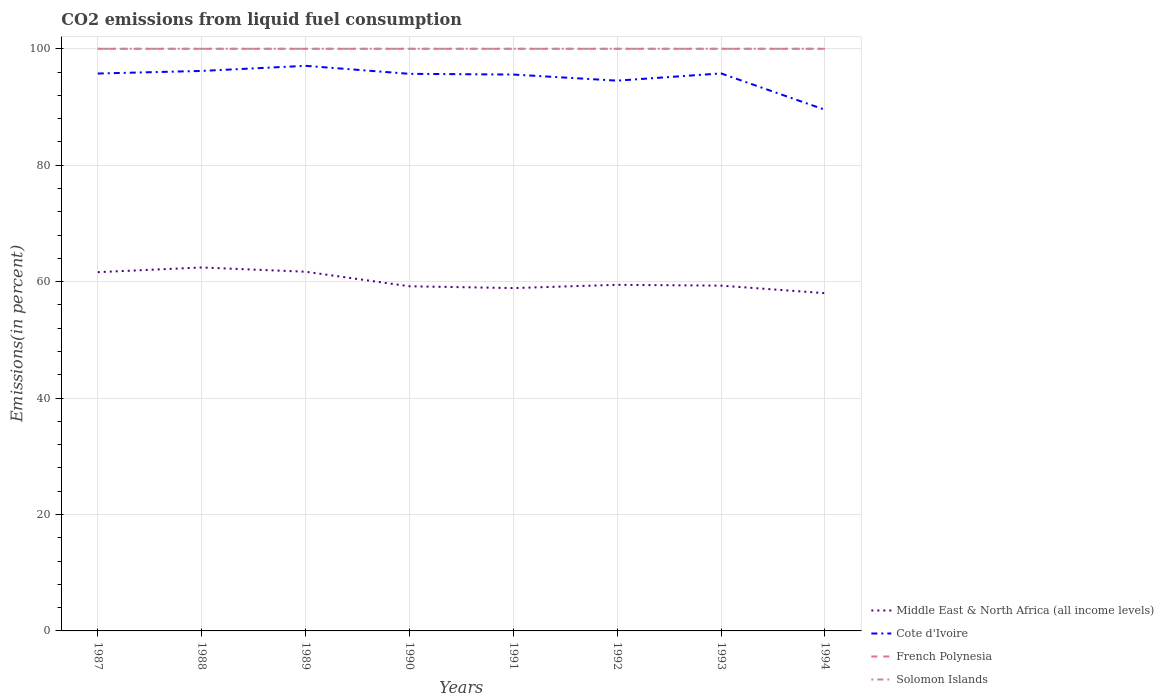Does the line corresponding to French Polynesia intersect with the line corresponding to Cote d'Ivoire?
Provide a short and direct response. No. Is the number of lines equal to the number of legend labels?
Provide a short and direct response. Yes. Across all years, what is the maximum total CO2 emitted in French Polynesia?
Make the answer very short. 100. In which year was the total CO2 emitted in Middle East & North Africa (all income levels) maximum?
Give a very brief answer. 1994. What is the difference between the highest and the lowest total CO2 emitted in Solomon Islands?
Your response must be concise. 0. Is the total CO2 emitted in Cote d'Ivoire strictly greater than the total CO2 emitted in Solomon Islands over the years?
Offer a terse response. Yes. How many years are there in the graph?
Provide a short and direct response. 8. Does the graph contain grids?
Your answer should be compact. Yes. Where does the legend appear in the graph?
Provide a succinct answer. Bottom right. What is the title of the graph?
Offer a terse response. CO2 emissions from liquid fuel consumption. Does "Indonesia" appear as one of the legend labels in the graph?
Make the answer very short. No. What is the label or title of the Y-axis?
Provide a short and direct response. Emissions(in percent). What is the Emissions(in percent) of Middle East & North Africa (all income levels) in 1987?
Your answer should be very brief. 61.63. What is the Emissions(in percent) in Cote d'Ivoire in 1987?
Your answer should be very brief. 95.75. What is the Emissions(in percent) in Middle East & North Africa (all income levels) in 1988?
Ensure brevity in your answer.  62.44. What is the Emissions(in percent) of Cote d'Ivoire in 1988?
Your answer should be very brief. 96.2. What is the Emissions(in percent) in Middle East & North Africa (all income levels) in 1989?
Make the answer very short. 61.7. What is the Emissions(in percent) of Cote d'Ivoire in 1989?
Offer a very short reply. 97.07. What is the Emissions(in percent) in Middle East & North Africa (all income levels) in 1990?
Keep it short and to the point. 59.21. What is the Emissions(in percent) of Cote d'Ivoire in 1990?
Your answer should be very brief. 95.7. What is the Emissions(in percent) in Solomon Islands in 1990?
Ensure brevity in your answer.  100. What is the Emissions(in percent) in Middle East & North Africa (all income levels) in 1991?
Your answer should be compact. 58.89. What is the Emissions(in percent) in Cote d'Ivoire in 1991?
Make the answer very short. 95.58. What is the Emissions(in percent) of French Polynesia in 1991?
Provide a short and direct response. 100. What is the Emissions(in percent) in Solomon Islands in 1991?
Give a very brief answer. 100. What is the Emissions(in percent) in Middle East & North Africa (all income levels) in 1992?
Your answer should be compact. 59.45. What is the Emissions(in percent) of Cote d'Ivoire in 1992?
Offer a very short reply. 94.53. What is the Emissions(in percent) in Solomon Islands in 1992?
Provide a succinct answer. 100. What is the Emissions(in percent) of Middle East & North Africa (all income levels) in 1993?
Keep it short and to the point. 59.31. What is the Emissions(in percent) in Cote d'Ivoire in 1993?
Offer a terse response. 95.77. What is the Emissions(in percent) in French Polynesia in 1993?
Keep it short and to the point. 100. What is the Emissions(in percent) in Middle East & North Africa (all income levels) in 1994?
Your response must be concise. 58.02. What is the Emissions(in percent) of Cote d'Ivoire in 1994?
Offer a terse response. 89.53. What is the Emissions(in percent) in Solomon Islands in 1994?
Provide a succinct answer. 100. Across all years, what is the maximum Emissions(in percent) of Middle East & North Africa (all income levels)?
Offer a very short reply. 62.44. Across all years, what is the maximum Emissions(in percent) in Cote d'Ivoire?
Provide a succinct answer. 97.07. Across all years, what is the maximum Emissions(in percent) in Solomon Islands?
Keep it short and to the point. 100. Across all years, what is the minimum Emissions(in percent) of Middle East & North Africa (all income levels)?
Ensure brevity in your answer.  58.02. Across all years, what is the minimum Emissions(in percent) in Cote d'Ivoire?
Make the answer very short. 89.53. Across all years, what is the minimum Emissions(in percent) of French Polynesia?
Provide a short and direct response. 100. Across all years, what is the minimum Emissions(in percent) in Solomon Islands?
Keep it short and to the point. 100. What is the total Emissions(in percent) of Middle East & North Africa (all income levels) in the graph?
Keep it short and to the point. 480.65. What is the total Emissions(in percent) of Cote d'Ivoire in the graph?
Make the answer very short. 760.12. What is the total Emissions(in percent) in French Polynesia in the graph?
Your response must be concise. 800. What is the total Emissions(in percent) of Solomon Islands in the graph?
Offer a terse response. 800. What is the difference between the Emissions(in percent) of Middle East & North Africa (all income levels) in 1987 and that in 1988?
Your answer should be compact. -0.81. What is the difference between the Emissions(in percent) of Cote d'Ivoire in 1987 and that in 1988?
Offer a very short reply. -0.45. What is the difference between the Emissions(in percent) of Solomon Islands in 1987 and that in 1988?
Make the answer very short. 0. What is the difference between the Emissions(in percent) of Middle East & North Africa (all income levels) in 1987 and that in 1989?
Your response must be concise. -0.07. What is the difference between the Emissions(in percent) in Cote d'Ivoire in 1987 and that in 1989?
Your answer should be compact. -1.32. What is the difference between the Emissions(in percent) in Middle East & North Africa (all income levels) in 1987 and that in 1990?
Your response must be concise. 2.42. What is the difference between the Emissions(in percent) in Cote d'Ivoire in 1987 and that in 1990?
Provide a short and direct response. 0.05. What is the difference between the Emissions(in percent) in Solomon Islands in 1987 and that in 1990?
Your answer should be very brief. 0. What is the difference between the Emissions(in percent) of Middle East & North Africa (all income levels) in 1987 and that in 1991?
Your response must be concise. 2.73. What is the difference between the Emissions(in percent) of Cote d'Ivoire in 1987 and that in 1991?
Provide a short and direct response. 0.18. What is the difference between the Emissions(in percent) in French Polynesia in 1987 and that in 1991?
Provide a short and direct response. 0. What is the difference between the Emissions(in percent) of Middle East & North Africa (all income levels) in 1987 and that in 1992?
Your answer should be very brief. 2.17. What is the difference between the Emissions(in percent) in Cote d'Ivoire in 1987 and that in 1992?
Offer a terse response. 1.22. What is the difference between the Emissions(in percent) of French Polynesia in 1987 and that in 1992?
Your response must be concise. 0. What is the difference between the Emissions(in percent) of Middle East & North Africa (all income levels) in 1987 and that in 1993?
Offer a terse response. 2.32. What is the difference between the Emissions(in percent) of Cote d'Ivoire in 1987 and that in 1993?
Provide a short and direct response. -0.02. What is the difference between the Emissions(in percent) of French Polynesia in 1987 and that in 1993?
Keep it short and to the point. 0. What is the difference between the Emissions(in percent) in Middle East & North Africa (all income levels) in 1987 and that in 1994?
Your answer should be very brief. 3.61. What is the difference between the Emissions(in percent) in Cote d'Ivoire in 1987 and that in 1994?
Give a very brief answer. 6.23. What is the difference between the Emissions(in percent) in French Polynesia in 1987 and that in 1994?
Give a very brief answer. 0. What is the difference between the Emissions(in percent) of Middle East & North Africa (all income levels) in 1988 and that in 1989?
Your response must be concise. 0.73. What is the difference between the Emissions(in percent) in Cote d'Ivoire in 1988 and that in 1989?
Provide a short and direct response. -0.88. What is the difference between the Emissions(in percent) in French Polynesia in 1988 and that in 1989?
Provide a succinct answer. 0. What is the difference between the Emissions(in percent) of Solomon Islands in 1988 and that in 1989?
Your answer should be compact. 0. What is the difference between the Emissions(in percent) of Middle East & North Africa (all income levels) in 1988 and that in 1990?
Your answer should be very brief. 3.23. What is the difference between the Emissions(in percent) in Cote d'Ivoire in 1988 and that in 1990?
Your response must be concise. 0.5. What is the difference between the Emissions(in percent) in Middle East & North Africa (all income levels) in 1988 and that in 1991?
Keep it short and to the point. 3.54. What is the difference between the Emissions(in percent) of Cote d'Ivoire in 1988 and that in 1991?
Ensure brevity in your answer.  0.62. What is the difference between the Emissions(in percent) of French Polynesia in 1988 and that in 1991?
Provide a succinct answer. 0. What is the difference between the Emissions(in percent) in Middle East & North Africa (all income levels) in 1988 and that in 1992?
Offer a very short reply. 2.98. What is the difference between the Emissions(in percent) of Cote d'Ivoire in 1988 and that in 1992?
Provide a succinct answer. 1.67. What is the difference between the Emissions(in percent) of Middle East & North Africa (all income levels) in 1988 and that in 1993?
Ensure brevity in your answer.  3.12. What is the difference between the Emissions(in percent) of Cote d'Ivoire in 1988 and that in 1993?
Offer a terse response. 0.43. What is the difference between the Emissions(in percent) in Middle East & North Africa (all income levels) in 1988 and that in 1994?
Give a very brief answer. 4.41. What is the difference between the Emissions(in percent) of Cote d'Ivoire in 1988 and that in 1994?
Give a very brief answer. 6.67. What is the difference between the Emissions(in percent) in Solomon Islands in 1988 and that in 1994?
Your response must be concise. 0. What is the difference between the Emissions(in percent) in Middle East & North Africa (all income levels) in 1989 and that in 1990?
Your answer should be compact. 2.5. What is the difference between the Emissions(in percent) in Cote d'Ivoire in 1989 and that in 1990?
Make the answer very short. 1.38. What is the difference between the Emissions(in percent) of French Polynesia in 1989 and that in 1990?
Your answer should be very brief. 0. What is the difference between the Emissions(in percent) in Middle East & North Africa (all income levels) in 1989 and that in 1991?
Give a very brief answer. 2.81. What is the difference between the Emissions(in percent) of Cote d'Ivoire in 1989 and that in 1991?
Your answer should be very brief. 1.5. What is the difference between the Emissions(in percent) in Middle East & North Africa (all income levels) in 1989 and that in 1992?
Provide a short and direct response. 2.25. What is the difference between the Emissions(in percent) of Cote d'Ivoire in 1989 and that in 1992?
Give a very brief answer. 2.55. What is the difference between the Emissions(in percent) of French Polynesia in 1989 and that in 1992?
Provide a succinct answer. 0. What is the difference between the Emissions(in percent) in Solomon Islands in 1989 and that in 1992?
Make the answer very short. 0. What is the difference between the Emissions(in percent) of Middle East & North Africa (all income levels) in 1989 and that in 1993?
Your answer should be very brief. 2.39. What is the difference between the Emissions(in percent) of Cote d'Ivoire in 1989 and that in 1993?
Make the answer very short. 1.31. What is the difference between the Emissions(in percent) of Middle East & North Africa (all income levels) in 1989 and that in 1994?
Ensure brevity in your answer.  3.68. What is the difference between the Emissions(in percent) of Cote d'Ivoire in 1989 and that in 1994?
Your response must be concise. 7.55. What is the difference between the Emissions(in percent) of French Polynesia in 1989 and that in 1994?
Your response must be concise. 0. What is the difference between the Emissions(in percent) in Middle East & North Africa (all income levels) in 1990 and that in 1991?
Offer a terse response. 0.31. What is the difference between the Emissions(in percent) of Cote d'Ivoire in 1990 and that in 1991?
Your answer should be compact. 0.12. What is the difference between the Emissions(in percent) in Middle East & North Africa (all income levels) in 1990 and that in 1992?
Ensure brevity in your answer.  -0.25. What is the difference between the Emissions(in percent) of Cote d'Ivoire in 1990 and that in 1992?
Provide a succinct answer. 1.17. What is the difference between the Emissions(in percent) of Solomon Islands in 1990 and that in 1992?
Make the answer very short. 0. What is the difference between the Emissions(in percent) in Middle East & North Africa (all income levels) in 1990 and that in 1993?
Provide a short and direct response. -0.11. What is the difference between the Emissions(in percent) in Cote d'Ivoire in 1990 and that in 1993?
Your response must be concise. -0.07. What is the difference between the Emissions(in percent) in Middle East & North Africa (all income levels) in 1990 and that in 1994?
Keep it short and to the point. 1.18. What is the difference between the Emissions(in percent) of Cote d'Ivoire in 1990 and that in 1994?
Offer a terse response. 6.17. What is the difference between the Emissions(in percent) of French Polynesia in 1990 and that in 1994?
Your answer should be very brief. 0. What is the difference between the Emissions(in percent) in Middle East & North Africa (all income levels) in 1991 and that in 1992?
Your response must be concise. -0.56. What is the difference between the Emissions(in percent) of Cote d'Ivoire in 1991 and that in 1992?
Ensure brevity in your answer.  1.05. What is the difference between the Emissions(in percent) in French Polynesia in 1991 and that in 1992?
Your response must be concise. 0. What is the difference between the Emissions(in percent) in Middle East & North Africa (all income levels) in 1991 and that in 1993?
Offer a very short reply. -0.42. What is the difference between the Emissions(in percent) in Cote d'Ivoire in 1991 and that in 1993?
Provide a succinct answer. -0.19. What is the difference between the Emissions(in percent) of Middle East & North Africa (all income levels) in 1991 and that in 1994?
Your answer should be compact. 0.87. What is the difference between the Emissions(in percent) of Cote d'Ivoire in 1991 and that in 1994?
Offer a terse response. 6.05. What is the difference between the Emissions(in percent) in Middle East & North Africa (all income levels) in 1992 and that in 1993?
Your response must be concise. 0.14. What is the difference between the Emissions(in percent) of Cote d'Ivoire in 1992 and that in 1993?
Your answer should be compact. -1.24. What is the difference between the Emissions(in percent) of French Polynesia in 1992 and that in 1993?
Your answer should be very brief. 0. What is the difference between the Emissions(in percent) in Middle East & North Africa (all income levels) in 1992 and that in 1994?
Keep it short and to the point. 1.43. What is the difference between the Emissions(in percent) of Cote d'Ivoire in 1992 and that in 1994?
Ensure brevity in your answer.  5. What is the difference between the Emissions(in percent) in Middle East & North Africa (all income levels) in 1993 and that in 1994?
Offer a terse response. 1.29. What is the difference between the Emissions(in percent) in Cote d'Ivoire in 1993 and that in 1994?
Make the answer very short. 6.24. What is the difference between the Emissions(in percent) of Middle East & North Africa (all income levels) in 1987 and the Emissions(in percent) of Cote d'Ivoire in 1988?
Give a very brief answer. -34.57. What is the difference between the Emissions(in percent) in Middle East & North Africa (all income levels) in 1987 and the Emissions(in percent) in French Polynesia in 1988?
Offer a terse response. -38.37. What is the difference between the Emissions(in percent) of Middle East & North Africa (all income levels) in 1987 and the Emissions(in percent) of Solomon Islands in 1988?
Your response must be concise. -38.37. What is the difference between the Emissions(in percent) of Cote d'Ivoire in 1987 and the Emissions(in percent) of French Polynesia in 1988?
Provide a short and direct response. -4.25. What is the difference between the Emissions(in percent) in Cote d'Ivoire in 1987 and the Emissions(in percent) in Solomon Islands in 1988?
Ensure brevity in your answer.  -4.25. What is the difference between the Emissions(in percent) of Middle East & North Africa (all income levels) in 1987 and the Emissions(in percent) of Cote d'Ivoire in 1989?
Provide a short and direct response. -35.45. What is the difference between the Emissions(in percent) in Middle East & North Africa (all income levels) in 1987 and the Emissions(in percent) in French Polynesia in 1989?
Provide a succinct answer. -38.37. What is the difference between the Emissions(in percent) in Middle East & North Africa (all income levels) in 1987 and the Emissions(in percent) in Solomon Islands in 1989?
Offer a terse response. -38.37. What is the difference between the Emissions(in percent) of Cote d'Ivoire in 1987 and the Emissions(in percent) of French Polynesia in 1989?
Ensure brevity in your answer.  -4.25. What is the difference between the Emissions(in percent) in Cote d'Ivoire in 1987 and the Emissions(in percent) in Solomon Islands in 1989?
Keep it short and to the point. -4.25. What is the difference between the Emissions(in percent) of Middle East & North Africa (all income levels) in 1987 and the Emissions(in percent) of Cote d'Ivoire in 1990?
Keep it short and to the point. -34.07. What is the difference between the Emissions(in percent) in Middle East & North Africa (all income levels) in 1987 and the Emissions(in percent) in French Polynesia in 1990?
Provide a succinct answer. -38.37. What is the difference between the Emissions(in percent) of Middle East & North Africa (all income levels) in 1987 and the Emissions(in percent) of Solomon Islands in 1990?
Offer a terse response. -38.37. What is the difference between the Emissions(in percent) of Cote d'Ivoire in 1987 and the Emissions(in percent) of French Polynesia in 1990?
Your answer should be compact. -4.25. What is the difference between the Emissions(in percent) of Cote d'Ivoire in 1987 and the Emissions(in percent) of Solomon Islands in 1990?
Your answer should be compact. -4.25. What is the difference between the Emissions(in percent) of Middle East & North Africa (all income levels) in 1987 and the Emissions(in percent) of Cote d'Ivoire in 1991?
Offer a very short reply. -33.95. What is the difference between the Emissions(in percent) in Middle East & North Africa (all income levels) in 1987 and the Emissions(in percent) in French Polynesia in 1991?
Your response must be concise. -38.37. What is the difference between the Emissions(in percent) in Middle East & North Africa (all income levels) in 1987 and the Emissions(in percent) in Solomon Islands in 1991?
Give a very brief answer. -38.37. What is the difference between the Emissions(in percent) in Cote d'Ivoire in 1987 and the Emissions(in percent) in French Polynesia in 1991?
Your answer should be compact. -4.25. What is the difference between the Emissions(in percent) of Cote d'Ivoire in 1987 and the Emissions(in percent) of Solomon Islands in 1991?
Provide a succinct answer. -4.25. What is the difference between the Emissions(in percent) of French Polynesia in 1987 and the Emissions(in percent) of Solomon Islands in 1991?
Your answer should be compact. 0. What is the difference between the Emissions(in percent) of Middle East & North Africa (all income levels) in 1987 and the Emissions(in percent) of Cote d'Ivoire in 1992?
Your answer should be very brief. -32.9. What is the difference between the Emissions(in percent) in Middle East & North Africa (all income levels) in 1987 and the Emissions(in percent) in French Polynesia in 1992?
Your answer should be compact. -38.37. What is the difference between the Emissions(in percent) in Middle East & North Africa (all income levels) in 1987 and the Emissions(in percent) in Solomon Islands in 1992?
Give a very brief answer. -38.37. What is the difference between the Emissions(in percent) in Cote d'Ivoire in 1987 and the Emissions(in percent) in French Polynesia in 1992?
Your answer should be compact. -4.25. What is the difference between the Emissions(in percent) of Cote d'Ivoire in 1987 and the Emissions(in percent) of Solomon Islands in 1992?
Offer a terse response. -4.25. What is the difference between the Emissions(in percent) of Middle East & North Africa (all income levels) in 1987 and the Emissions(in percent) of Cote d'Ivoire in 1993?
Give a very brief answer. -34.14. What is the difference between the Emissions(in percent) of Middle East & North Africa (all income levels) in 1987 and the Emissions(in percent) of French Polynesia in 1993?
Provide a short and direct response. -38.37. What is the difference between the Emissions(in percent) of Middle East & North Africa (all income levels) in 1987 and the Emissions(in percent) of Solomon Islands in 1993?
Provide a short and direct response. -38.37. What is the difference between the Emissions(in percent) in Cote d'Ivoire in 1987 and the Emissions(in percent) in French Polynesia in 1993?
Provide a short and direct response. -4.25. What is the difference between the Emissions(in percent) in Cote d'Ivoire in 1987 and the Emissions(in percent) in Solomon Islands in 1993?
Provide a succinct answer. -4.25. What is the difference between the Emissions(in percent) in French Polynesia in 1987 and the Emissions(in percent) in Solomon Islands in 1993?
Make the answer very short. 0. What is the difference between the Emissions(in percent) in Middle East & North Africa (all income levels) in 1987 and the Emissions(in percent) in Cote d'Ivoire in 1994?
Provide a succinct answer. -27.9. What is the difference between the Emissions(in percent) in Middle East & North Africa (all income levels) in 1987 and the Emissions(in percent) in French Polynesia in 1994?
Your answer should be very brief. -38.37. What is the difference between the Emissions(in percent) in Middle East & North Africa (all income levels) in 1987 and the Emissions(in percent) in Solomon Islands in 1994?
Give a very brief answer. -38.37. What is the difference between the Emissions(in percent) of Cote d'Ivoire in 1987 and the Emissions(in percent) of French Polynesia in 1994?
Give a very brief answer. -4.25. What is the difference between the Emissions(in percent) of Cote d'Ivoire in 1987 and the Emissions(in percent) of Solomon Islands in 1994?
Offer a very short reply. -4.25. What is the difference between the Emissions(in percent) in French Polynesia in 1987 and the Emissions(in percent) in Solomon Islands in 1994?
Provide a succinct answer. 0. What is the difference between the Emissions(in percent) of Middle East & North Africa (all income levels) in 1988 and the Emissions(in percent) of Cote d'Ivoire in 1989?
Provide a succinct answer. -34.64. What is the difference between the Emissions(in percent) of Middle East & North Africa (all income levels) in 1988 and the Emissions(in percent) of French Polynesia in 1989?
Your response must be concise. -37.56. What is the difference between the Emissions(in percent) of Middle East & North Africa (all income levels) in 1988 and the Emissions(in percent) of Solomon Islands in 1989?
Give a very brief answer. -37.56. What is the difference between the Emissions(in percent) of Cote d'Ivoire in 1988 and the Emissions(in percent) of French Polynesia in 1989?
Keep it short and to the point. -3.8. What is the difference between the Emissions(in percent) of Cote d'Ivoire in 1988 and the Emissions(in percent) of Solomon Islands in 1989?
Make the answer very short. -3.8. What is the difference between the Emissions(in percent) of Middle East & North Africa (all income levels) in 1988 and the Emissions(in percent) of Cote d'Ivoire in 1990?
Your response must be concise. -33.26. What is the difference between the Emissions(in percent) of Middle East & North Africa (all income levels) in 1988 and the Emissions(in percent) of French Polynesia in 1990?
Your answer should be compact. -37.56. What is the difference between the Emissions(in percent) in Middle East & North Africa (all income levels) in 1988 and the Emissions(in percent) in Solomon Islands in 1990?
Provide a short and direct response. -37.56. What is the difference between the Emissions(in percent) in Cote d'Ivoire in 1988 and the Emissions(in percent) in French Polynesia in 1990?
Keep it short and to the point. -3.8. What is the difference between the Emissions(in percent) in Cote d'Ivoire in 1988 and the Emissions(in percent) in Solomon Islands in 1990?
Make the answer very short. -3.8. What is the difference between the Emissions(in percent) in French Polynesia in 1988 and the Emissions(in percent) in Solomon Islands in 1990?
Provide a short and direct response. 0. What is the difference between the Emissions(in percent) in Middle East & North Africa (all income levels) in 1988 and the Emissions(in percent) in Cote d'Ivoire in 1991?
Keep it short and to the point. -33.14. What is the difference between the Emissions(in percent) of Middle East & North Africa (all income levels) in 1988 and the Emissions(in percent) of French Polynesia in 1991?
Make the answer very short. -37.56. What is the difference between the Emissions(in percent) of Middle East & North Africa (all income levels) in 1988 and the Emissions(in percent) of Solomon Islands in 1991?
Provide a succinct answer. -37.56. What is the difference between the Emissions(in percent) of Cote d'Ivoire in 1988 and the Emissions(in percent) of French Polynesia in 1991?
Provide a succinct answer. -3.8. What is the difference between the Emissions(in percent) of Cote d'Ivoire in 1988 and the Emissions(in percent) of Solomon Islands in 1991?
Give a very brief answer. -3.8. What is the difference between the Emissions(in percent) of French Polynesia in 1988 and the Emissions(in percent) of Solomon Islands in 1991?
Keep it short and to the point. 0. What is the difference between the Emissions(in percent) of Middle East & North Africa (all income levels) in 1988 and the Emissions(in percent) of Cote d'Ivoire in 1992?
Your response must be concise. -32.09. What is the difference between the Emissions(in percent) in Middle East & North Africa (all income levels) in 1988 and the Emissions(in percent) in French Polynesia in 1992?
Offer a very short reply. -37.56. What is the difference between the Emissions(in percent) of Middle East & North Africa (all income levels) in 1988 and the Emissions(in percent) of Solomon Islands in 1992?
Give a very brief answer. -37.56. What is the difference between the Emissions(in percent) of Cote d'Ivoire in 1988 and the Emissions(in percent) of French Polynesia in 1992?
Your answer should be very brief. -3.8. What is the difference between the Emissions(in percent) of Cote d'Ivoire in 1988 and the Emissions(in percent) of Solomon Islands in 1992?
Ensure brevity in your answer.  -3.8. What is the difference between the Emissions(in percent) in French Polynesia in 1988 and the Emissions(in percent) in Solomon Islands in 1992?
Your response must be concise. 0. What is the difference between the Emissions(in percent) in Middle East & North Africa (all income levels) in 1988 and the Emissions(in percent) in Cote d'Ivoire in 1993?
Offer a terse response. -33.33. What is the difference between the Emissions(in percent) of Middle East & North Africa (all income levels) in 1988 and the Emissions(in percent) of French Polynesia in 1993?
Offer a very short reply. -37.56. What is the difference between the Emissions(in percent) of Middle East & North Africa (all income levels) in 1988 and the Emissions(in percent) of Solomon Islands in 1993?
Your answer should be compact. -37.56. What is the difference between the Emissions(in percent) in Cote d'Ivoire in 1988 and the Emissions(in percent) in French Polynesia in 1993?
Keep it short and to the point. -3.8. What is the difference between the Emissions(in percent) in Cote d'Ivoire in 1988 and the Emissions(in percent) in Solomon Islands in 1993?
Make the answer very short. -3.8. What is the difference between the Emissions(in percent) of Middle East & North Africa (all income levels) in 1988 and the Emissions(in percent) of Cote d'Ivoire in 1994?
Offer a very short reply. -27.09. What is the difference between the Emissions(in percent) of Middle East & North Africa (all income levels) in 1988 and the Emissions(in percent) of French Polynesia in 1994?
Your answer should be very brief. -37.56. What is the difference between the Emissions(in percent) of Middle East & North Africa (all income levels) in 1988 and the Emissions(in percent) of Solomon Islands in 1994?
Make the answer very short. -37.56. What is the difference between the Emissions(in percent) in Cote d'Ivoire in 1988 and the Emissions(in percent) in French Polynesia in 1994?
Provide a succinct answer. -3.8. What is the difference between the Emissions(in percent) of Cote d'Ivoire in 1988 and the Emissions(in percent) of Solomon Islands in 1994?
Offer a terse response. -3.8. What is the difference between the Emissions(in percent) in Middle East & North Africa (all income levels) in 1989 and the Emissions(in percent) in Cote d'Ivoire in 1990?
Offer a very short reply. -34. What is the difference between the Emissions(in percent) in Middle East & North Africa (all income levels) in 1989 and the Emissions(in percent) in French Polynesia in 1990?
Provide a succinct answer. -38.3. What is the difference between the Emissions(in percent) of Middle East & North Africa (all income levels) in 1989 and the Emissions(in percent) of Solomon Islands in 1990?
Provide a succinct answer. -38.3. What is the difference between the Emissions(in percent) of Cote d'Ivoire in 1989 and the Emissions(in percent) of French Polynesia in 1990?
Make the answer very short. -2.93. What is the difference between the Emissions(in percent) in Cote d'Ivoire in 1989 and the Emissions(in percent) in Solomon Islands in 1990?
Your answer should be very brief. -2.93. What is the difference between the Emissions(in percent) in Middle East & North Africa (all income levels) in 1989 and the Emissions(in percent) in Cote d'Ivoire in 1991?
Keep it short and to the point. -33.87. What is the difference between the Emissions(in percent) of Middle East & North Africa (all income levels) in 1989 and the Emissions(in percent) of French Polynesia in 1991?
Your answer should be compact. -38.3. What is the difference between the Emissions(in percent) of Middle East & North Africa (all income levels) in 1989 and the Emissions(in percent) of Solomon Islands in 1991?
Offer a terse response. -38.3. What is the difference between the Emissions(in percent) in Cote d'Ivoire in 1989 and the Emissions(in percent) in French Polynesia in 1991?
Keep it short and to the point. -2.93. What is the difference between the Emissions(in percent) of Cote d'Ivoire in 1989 and the Emissions(in percent) of Solomon Islands in 1991?
Keep it short and to the point. -2.93. What is the difference between the Emissions(in percent) of Middle East & North Africa (all income levels) in 1989 and the Emissions(in percent) of Cote d'Ivoire in 1992?
Give a very brief answer. -32.83. What is the difference between the Emissions(in percent) in Middle East & North Africa (all income levels) in 1989 and the Emissions(in percent) in French Polynesia in 1992?
Give a very brief answer. -38.3. What is the difference between the Emissions(in percent) in Middle East & North Africa (all income levels) in 1989 and the Emissions(in percent) in Solomon Islands in 1992?
Provide a succinct answer. -38.3. What is the difference between the Emissions(in percent) of Cote d'Ivoire in 1989 and the Emissions(in percent) of French Polynesia in 1992?
Ensure brevity in your answer.  -2.93. What is the difference between the Emissions(in percent) of Cote d'Ivoire in 1989 and the Emissions(in percent) of Solomon Islands in 1992?
Ensure brevity in your answer.  -2.93. What is the difference between the Emissions(in percent) of French Polynesia in 1989 and the Emissions(in percent) of Solomon Islands in 1992?
Ensure brevity in your answer.  0. What is the difference between the Emissions(in percent) in Middle East & North Africa (all income levels) in 1989 and the Emissions(in percent) in Cote d'Ivoire in 1993?
Your answer should be very brief. -34.07. What is the difference between the Emissions(in percent) in Middle East & North Africa (all income levels) in 1989 and the Emissions(in percent) in French Polynesia in 1993?
Give a very brief answer. -38.3. What is the difference between the Emissions(in percent) of Middle East & North Africa (all income levels) in 1989 and the Emissions(in percent) of Solomon Islands in 1993?
Provide a short and direct response. -38.3. What is the difference between the Emissions(in percent) in Cote d'Ivoire in 1989 and the Emissions(in percent) in French Polynesia in 1993?
Offer a terse response. -2.93. What is the difference between the Emissions(in percent) of Cote d'Ivoire in 1989 and the Emissions(in percent) of Solomon Islands in 1993?
Offer a terse response. -2.93. What is the difference between the Emissions(in percent) in French Polynesia in 1989 and the Emissions(in percent) in Solomon Islands in 1993?
Offer a terse response. 0. What is the difference between the Emissions(in percent) in Middle East & North Africa (all income levels) in 1989 and the Emissions(in percent) in Cote d'Ivoire in 1994?
Your answer should be very brief. -27.82. What is the difference between the Emissions(in percent) of Middle East & North Africa (all income levels) in 1989 and the Emissions(in percent) of French Polynesia in 1994?
Your response must be concise. -38.3. What is the difference between the Emissions(in percent) of Middle East & North Africa (all income levels) in 1989 and the Emissions(in percent) of Solomon Islands in 1994?
Make the answer very short. -38.3. What is the difference between the Emissions(in percent) in Cote d'Ivoire in 1989 and the Emissions(in percent) in French Polynesia in 1994?
Your answer should be compact. -2.93. What is the difference between the Emissions(in percent) in Cote d'Ivoire in 1989 and the Emissions(in percent) in Solomon Islands in 1994?
Ensure brevity in your answer.  -2.93. What is the difference between the Emissions(in percent) of French Polynesia in 1989 and the Emissions(in percent) of Solomon Islands in 1994?
Offer a very short reply. 0. What is the difference between the Emissions(in percent) of Middle East & North Africa (all income levels) in 1990 and the Emissions(in percent) of Cote d'Ivoire in 1991?
Make the answer very short. -36.37. What is the difference between the Emissions(in percent) in Middle East & North Africa (all income levels) in 1990 and the Emissions(in percent) in French Polynesia in 1991?
Your answer should be compact. -40.79. What is the difference between the Emissions(in percent) of Middle East & North Africa (all income levels) in 1990 and the Emissions(in percent) of Solomon Islands in 1991?
Your answer should be compact. -40.79. What is the difference between the Emissions(in percent) in Cote d'Ivoire in 1990 and the Emissions(in percent) in French Polynesia in 1991?
Provide a short and direct response. -4.3. What is the difference between the Emissions(in percent) in Cote d'Ivoire in 1990 and the Emissions(in percent) in Solomon Islands in 1991?
Give a very brief answer. -4.3. What is the difference between the Emissions(in percent) of Middle East & North Africa (all income levels) in 1990 and the Emissions(in percent) of Cote d'Ivoire in 1992?
Give a very brief answer. -35.32. What is the difference between the Emissions(in percent) of Middle East & North Africa (all income levels) in 1990 and the Emissions(in percent) of French Polynesia in 1992?
Keep it short and to the point. -40.79. What is the difference between the Emissions(in percent) of Middle East & North Africa (all income levels) in 1990 and the Emissions(in percent) of Solomon Islands in 1992?
Give a very brief answer. -40.79. What is the difference between the Emissions(in percent) in Cote d'Ivoire in 1990 and the Emissions(in percent) in French Polynesia in 1992?
Give a very brief answer. -4.3. What is the difference between the Emissions(in percent) of Cote d'Ivoire in 1990 and the Emissions(in percent) of Solomon Islands in 1992?
Provide a short and direct response. -4.3. What is the difference between the Emissions(in percent) of French Polynesia in 1990 and the Emissions(in percent) of Solomon Islands in 1992?
Offer a terse response. 0. What is the difference between the Emissions(in percent) of Middle East & North Africa (all income levels) in 1990 and the Emissions(in percent) of Cote d'Ivoire in 1993?
Your answer should be very brief. -36.56. What is the difference between the Emissions(in percent) in Middle East & North Africa (all income levels) in 1990 and the Emissions(in percent) in French Polynesia in 1993?
Ensure brevity in your answer.  -40.79. What is the difference between the Emissions(in percent) of Middle East & North Africa (all income levels) in 1990 and the Emissions(in percent) of Solomon Islands in 1993?
Offer a terse response. -40.79. What is the difference between the Emissions(in percent) of Cote d'Ivoire in 1990 and the Emissions(in percent) of French Polynesia in 1993?
Make the answer very short. -4.3. What is the difference between the Emissions(in percent) of Cote d'Ivoire in 1990 and the Emissions(in percent) of Solomon Islands in 1993?
Give a very brief answer. -4.3. What is the difference between the Emissions(in percent) of Middle East & North Africa (all income levels) in 1990 and the Emissions(in percent) of Cote d'Ivoire in 1994?
Provide a short and direct response. -30.32. What is the difference between the Emissions(in percent) of Middle East & North Africa (all income levels) in 1990 and the Emissions(in percent) of French Polynesia in 1994?
Keep it short and to the point. -40.79. What is the difference between the Emissions(in percent) of Middle East & North Africa (all income levels) in 1990 and the Emissions(in percent) of Solomon Islands in 1994?
Your answer should be compact. -40.79. What is the difference between the Emissions(in percent) in Cote d'Ivoire in 1990 and the Emissions(in percent) in French Polynesia in 1994?
Your answer should be compact. -4.3. What is the difference between the Emissions(in percent) in Cote d'Ivoire in 1990 and the Emissions(in percent) in Solomon Islands in 1994?
Keep it short and to the point. -4.3. What is the difference between the Emissions(in percent) in French Polynesia in 1990 and the Emissions(in percent) in Solomon Islands in 1994?
Your answer should be very brief. 0. What is the difference between the Emissions(in percent) of Middle East & North Africa (all income levels) in 1991 and the Emissions(in percent) of Cote d'Ivoire in 1992?
Offer a terse response. -35.63. What is the difference between the Emissions(in percent) in Middle East & North Africa (all income levels) in 1991 and the Emissions(in percent) in French Polynesia in 1992?
Make the answer very short. -41.11. What is the difference between the Emissions(in percent) of Middle East & North Africa (all income levels) in 1991 and the Emissions(in percent) of Solomon Islands in 1992?
Provide a short and direct response. -41.11. What is the difference between the Emissions(in percent) of Cote d'Ivoire in 1991 and the Emissions(in percent) of French Polynesia in 1992?
Your answer should be compact. -4.42. What is the difference between the Emissions(in percent) in Cote d'Ivoire in 1991 and the Emissions(in percent) in Solomon Islands in 1992?
Give a very brief answer. -4.42. What is the difference between the Emissions(in percent) in Middle East & North Africa (all income levels) in 1991 and the Emissions(in percent) in Cote d'Ivoire in 1993?
Provide a short and direct response. -36.87. What is the difference between the Emissions(in percent) of Middle East & North Africa (all income levels) in 1991 and the Emissions(in percent) of French Polynesia in 1993?
Offer a very short reply. -41.11. What is the difference between the Emissions(in percent) in Middle East & North Africa (all income levels) in 1991 and the Emissions(in percent) in Solomon Islands in 1993?
Provide a short and direct response. -41.11. What is the difference between the Emissions(in percent) of Cote d'Ivoire in 1991 and the Emissions(in percent) of French Polynesia in 1993?
Your answer should be very brief. -4.42. What is the difference between the Emissions(in percent) of Cote d'Ivoire in 1991 and the Emissions(in percent) of Solomon Islands in 1993?
Offer a very short reply. -4.42. What is the difference between the Emissions(in percent) of Middle East & North Africa (all income levels) in 1991 and the Emissions(in percent) of Cote d'Ivoire in 1994?
Give a very brief answer. -30.63. What is the difference between the Emissions(in percent) in Middle East & North Africa (all income levels) in 1991 and the Emissions(in percent) in French Polynesia in 1994?
Provide a short and direct response. -41.11. What is the difference between the Emissions(in percent) of Middle East & North Africa (all income levels) in 1991 and the Emissions(in percent) of Solomon Islands in 1994?
Your response must be concise. -41.11. What is the difference between the Emissions(in percent) of Cote d'Ivoire in 1991 and the Emissions(in percent) of French Polynesia in 1994?
Make the answer very short. -4.42. What is the difference between the Emissions(in percent) in Cote d'Ivoire in 1991 and the Emissions(in percent) in Solomon Islands in 1994?
Offer a terse response. -4.42. What is the difference between the Emissions(in percent) of Middle East & North Africa (all income levels) in 1992 and the Emissions(in percent) of Cote d'Ivoire in 1993?
Provide a short and direct response. -36.31. What is the difference between the Emissions(in percent) in Middle East & North Africa (all income levels) in 1992 and the Emissions(in percent) in French Polynesia in 1993?
Offer a terse response. -40.55. What is the difference between the Emissions(in percent) of Middle East & North Africa (all income levels) in 1992 and the Emissions(in percent) of Solomon Islands in 1993?
Your answer should be compact. -40.55. What is the difference between the Emissions(in percent) of Cote d'Ivoire in 1992 and the Emissions(in percent) of French Polynesia in 1993?
Make the answer very short. -5.47. What is the difference between the Emissions(in percent) in Cote d'Ivoire in 1992 and the Emissions(in percent) in Solomon Islands in 1993?
Your response must be concise. -5.47. What is the difference between the Emissions(in percent) of Middle East & North Africa (all income levels) in 1992 and the Emissions(in percent) of Cote d'Ivoire in 1994?
Ensure brevity in your answer.  -30.07. What is the difference between the Emissions(in percent) in Middle East & North Africa (all income levels) in 1992 and the Emissions(in percent) in French Polynesia in 1994?
Make the answer very short. -40.55. What is the difference between the Emissions(in percent) in Middle East & North Africa (all income levels) in 1992 and the Emissions(in percent) in Solomon Islands in 1994?
Provide a succinct answer. -40.55. What is the difference between the Emissions(in percent) of Cote d'Ivoire in 1992 and the Emissions(in percent) of French Polynesia in 1994?
Offer a very short reply. -5.47. What is the difference between the Emissions(in percent) of Cote d'Ivoire in 1992 and the Emissions(in percent) of Solomon Islands in 1994?
Your answer should be very brief. -5.47. What is the difference between the Emissions(in percent) in Middle East & North Africa (all income levels) in 1993 and the Emissions(in percent) in Cote d'Ivoire in 1994?
Your answer should be compact. -30.21. What is the difference between the Emissions(in percent) in Middle East & North Africa (all income levels) in 1993 and the Emissions(in percent) in French Polynesia in 1994?
Keep it short and to the point. -40.69. What is the difference between the Emissions(in percent) in Middle East & North Africa (all income levels) in 1993 and the Emissions(in percent) in Solomon Islands in 1994?
Make the answer very short. -40.69. What is the difference between the Emissions(in percent) of Cote d'Ivoire in 1993 and the Emissions(in percent) of French Polynesia in 1994?
Keep it short and to the point. -4.23. What is the difference between the Emissions(in percent) in Cote d'Ivoire in 1993 and the Emissions(in percent) in Solomon Islands in 1994?
Ensure brevity in your answer.  -4.23. What is the difference between the Emissions(in percent) of French Polynesia in 1993 and the Emissions(in percent) of Solomon Islands in 1994?
Offer a terse response. 0. What is the average Emissions(in percent) of Middle East & North Africa (all income levels) per year?
Keep it short and to the point. 60.08. What is the average Emissions(in percent) of Cote d'Ivoire per year?
Offer a very short reply. 95.01. What is the average Emissions(in percent) in French Polynesia per year?
Keep it short and to the point. 100. What is the average Emissions(in percent) in Solomon Islands per year?
Provide a short and direct response. 100. In the year 1987, what is the difference between the Emissions(in percent) in Middle East & North Africa (all income levels) and Emissions(in percent) in Cote d'Ivoire?
Your answer should be compact. -34.12. In the year 1987, what is the difference between the Emissions(in percent) of Middle East & North Africa (all income levels) and Emissions(in percent) of French Polynesia?
Your answer should be compact. -38.37. In the year 1987, what is the difference between the Emissions(in percent) of Middle East & North Africa (all income levels) and Emissions(in percent) of Solomon Islands?
Offer a very short reply. -38.37. In the year 1987, what is the difference between the Emissions(in percent) in Cote d'Ivoire and Emissions(in percent) in French Polynesia?
Provide a short and direct response. -4.25. In the year 1987, what is the difference between the Emissions(in percent) of Cote d'Ivoire and Emissions(in percent) of Solomon Islands?
Provide a succinct answer. -4.25. In the year 1987, what is the difference between the Emissions(in percent) in French Polynesia and Emissions(in percent) in Solomon Islands?
Your answer should be compact. 0. In the year 1988, what is the difference between the Emissions(in percent) of Middle East & North Africa (all income levels) and Emissions(in percent) of Cote d'Ivoire?
Provide a succinct answer. -33.76. In the year 1988, what is the difference between the Emissions(in percent) in Middle East & North Africa (all income levels) and Emissions(in percent) in French Polynesia?
Offer a terse response. -37.56. In the year 1988, what is the difference between the Emissions(in percent) in Middle East & North Africa (all income levels) and Emissions(in percent) in Solomon Islands?
Keep it short and to the point. -37.56. In the year 1988, what is the difference between the Emissions(in percent) of Cote d'Ivoire and Emissions(in percent) of French Polynesia?
Offer a very short reply. -3.8. In the year 1988, what is the difference between the Emissions(in percent) of Cote d'Ivoire and Emissions(in percent) of Solomon Islands?
Your response must be concise. -3.8. In the year 1988, what is the difference between the Emissions(in percent) of French Polynesia and Emissions(in percent) of Solomon Islands?
Provide a short and direct response. 0. In the year 1989, what is the difference between the Emissions(in percent) in Middle East & North Africa (all income levels) and Emissions(in percent) in Cote d'Ivoire?
Provide a short and direct response. -35.37. In the year 1989, what is the difference between the Emissions(in percent) of Middle East & North Africa (all income levels) and Emissions(in percent) of French Polynesia?
Keep it short and to the point. -38.3. In the year 1989, what is the difference between the Emissions(in percent) of Middle East & North Africa (all income levels) and Emissions(in percent) of Solomon Islands?
Offer a terse response. -38.3. In the year 1989, what is the difference between the Emissions(in percent) of Cote d'Ivoire and Emissions(in percent) of French Polynesia?
Provide a short and direct response. -2.93. In the year 1989, what is the difference between the Emissions(in percent) in Cote d'Ivoire and Emissions(in percent) in Solomon Islands?
Your answer should be compact. -2.93. In the year 1989, what is the difference between the Emissions(in percent) of French Polynesia and Emissions(in percent) of Solomon Islands?
Your answer should be compact. 0. In the year 1990, what is the difference between the Emissions(in percent) of Middle East & North Africa (all income levels) and Emissions(in percent) of Cote d'Ivoire?
Offer a very short reply. -36.49. In the year 1990, what is the difference between the Emissions(in percent) of Middle East & North Africa (all income levels) and Emissions(in percent) of French Polynesia?
Your response must be concise. -40.79. In the year 1990, what is the difference between the Emissions(in percent) in Middle East & North Africa (all income levels) and Emissions(in percent) in Solomon Islands?
Your response must be concise. -40.79. In the year 1990, what is the difference between the Emissions(in percent) in Cote d'Ivoire and Emissions(in percent) in French Polynesia?
Keep it short and to the point. -4.3. In the year 1990, what is the difference between the Emissions(in percent) in Cote d'Ivoire and Emissions(in percent) in Solomon Islands?
Provide a short and direct response. -4.3. In the year 1991, what is the difference between the Emissions(in percent) in Middle East & North Africa (all income levels) and Emissions(in percent) in Cote d'Ivoire?
Ensure brevity in your answer.  -36.68. In the year 1991, what is the difference between the Emissions(in percent) of Middle East & North Africa (all income levels) and Emissions(in percent) of French Polynesia?
Provide a short and direct response. -41.11. In the year 1991, what is the difference between the Emissions(in percent) of Middle East & North Africa (all income levels) and Emissions(in percent) of Solomon Islands?
Provide a short and direct response. -41.11. In the year 1991, what is the difference between the Emissions(in percent) in Cote d'Ivoire and Emissions(in percent) in French Polynesia?
Give a very brief answer. -4.42. In the year 1991, what is the difference between the Emissions(in percent) of Cote d'Ivoire and Emissions(in percent) of Solomon Islands?
Make the answer very short. -4.42. In the year 1991, what is the difference between the Emissions(in percent) in French Polynesia and Emissions(in percent) in Solomon Islands?
Offer a very short reply. 0. In the year 1992, what is the difference between the Emissions(in percent) in Middle East & North Africa (all income levels) and Emissions(in percent) in Cote d'Ivoire?
Ensure brevity in your answer.  -35.07. In the year 1992, what is the difference between the Emissions(in percent) of Middle East & North Africa (all income levels) and Emissions(in percent) of French Polynesia?
Your answer should be compact. -40.55. In the year 1992, what is the difference between the Emissions(in percent) in Middle East & North Africa (all income levels) and Emissions(in percent) in Solomon Islands?
Ensure brevity in your answer.  -40.55. In the year 1992, what is the difference between the Emissions(in percent) in Cote d'Ivoire and Emissions(in percent) in French Polynesia?
Give a very brief answer. -5.47. In the year 1992, what is the difference between the Emissions(in percent) of Cote d'Ivoire and Emissions(in percent) of Solomon Islands?
Offer a very short reply. -5.47. In the year 1992, what is the difference between the Emissions(in percent) of French Polynesia and Emissions(in percent) of Solomon Islands?
Your response must be concise. 0. In the year 1993, what is the difference between the Emissions(in percent) of Middle East & North Africa (all income levels) and Emissions(in percent) of Cote d'Ivoire?
Provide a short and direct response. -36.46. In the year 1993, what is the difference between the Emissions(in percent) in Middle East & North Africa (all income levels) and Emissions(in percent) in French Polynesia?
Ensure brevity in your answer.  -40.69. In the year 1993, what is the difference between the Emissions(in percent) of Middle East & North Africa (all income levels) and Emissions(in percent) of Solomon Islands?
Offer a very short reply. -40.69. In the year 1993, what is the difference between the Emissions(in percent) of Cote d'Ivoire and Emissions(in percent) of French Polynesia?
Make the answer very short. -4.23. In the year 1993, what is the difference between the Emissions(in percent) in Cote d'Ivoire and Emissions(in percent) in Solomon Islands?
Give a very brief answer. -4.23. In the year 1993, what is the difference between the Emissions(in percent) in French Polynesia and Emissions(in percent) in Solomon Islands?
Your answer should be very brief. 0. In the year 1994, what is the difference between the Emissions(in percent) of Middle East & North Africa (all income levels) and Emissions(in percent) of Cote d'Ivoire?
Offer a terse response. -31.5. In the year 1994, what is the difference between the Emissions(in percent) in Middle East & North Africa (all income levels) and Emissions(in percent) in French Polynesia?
Keep it short and to the point. -41.98. In the year 1994, what is the difference between the Emissions(in percent) in Middle East & North Africa (all income levels) and Emissions(in percent) in Solomon Islands?
Offer a very short reply. -41.98. In the year 1994, what is the difference between the Emissions(in percent) of Cote d'Ivoire and Emissions(in percent) of French Polynesia?
Your answer should be very brief. -10.47. In the year 1994, what is the difference between the Emissions(in percent) in Cote d'Ivoire and Emissions(in percent) in Solomon Islands?
Your response must be concise. -10.47. What is the ratio of the Emissions(in percent) of Middle East & North Africa (all income levels) in 1987 to that in 1988?
Your answer should be compact. 0.99. What is the ratio of the Emissions(in percent) in French Polynesia in 1987 to that in 1988?
Offer a very short reply. 1. What is the ratio of the Emissions(in percent) in Solomon Islands in 1987 to that in 1988?
Offer a very short reply. 1. What is the ratio of the Emissions(in percent) of Cote d'Ivoire in 1987 to that in 1989?
Offer a very short reply. 0.99. What is the ratio of the Emissions(in percent) in Middle East & North Africa (all income levels) in 1987 to that in 1990?
Make the answer very short. 1.04. What is the ratio of the Emissions(in percent) in French Polynesia in 1987 to that in 1990?
Your response must be concise. 1. What is the ratio of the Emissions(in percent) of Solomon Islands in 1987 to that in 1990?
Your answer should be compact. 1. What is the ratio of the Emissions(in percent) in Middle East & North Africa (all income levels) in 1987 to that in 1991?
Provide a succinct answer. 1.05. What is the ratio of the Emissions(in percent) in French Polynesia in 1987 to that in 1991?
Make the answer very short. 1. What is the ratio of the Emissions(in percent) in Solomon Islands in 1987 to that in 1991?
Ensure brevity in your answer.  1. What is the ratio of the Emissions(in percent) in Middle East & North Africa (all income levels) in 1987 to that in 1992?
Offer a terse response. 1.04. What is the ratio of the Emissions(in percent) in Cote d'Ivoire in 1987 to that in 1992?
Ensure brevity in your answer.  1.01. What is the ratio of the Emissions(in percent) in Solomon Islands in 1987 to that in 1992?
Your response must be concise. 1. What is the ratio of the Emissions(in percent) of Middle East & North Africa (all income levels) in 1987 to that in 1993?
Make the answer very short. 1.04. What is the ratio of the Emissions(in percent) of Middle East & North Africa (all income levels) in 1987 to that in 1994?
Give a very brief answer. 1.06. What is the ratio of the Emissions(in percent) of Cote d'Ivoire in 1987 to that in 1994?
Ensure brevity in your answer.  1.07. What is the ratio of the Emissions(in percent) of Solomon Islands in 1987 to that in 1994?
Your answer should be very brief. 1. What is the ratio of the Emissions(in percent) of Middle East & North Africa (all income levels) in 1988 to that in 1989?
Ensure brevity in your answer.  1.01. What is the ratio of the Emissions(in percent) in French Polynesia in 1988 to that in 1989?
Give a very brief answer. 1. What is the ratio of the Emissions(in percent) in Middle East & North Africa (all income levels) in 1988 to that in 1990?
Ensure brevity in your answer.  1.05. What is the ratio of the Emissions(in percent) in Cote d'Ivoire in 1988 to that in 1990?
Ensure brevity in your answer.  1.01. What is the ratio of the Emissions(in percent) of French Polynesia in 1988 to that in 1990?
Provide a short and direct response. 1. What is the ratio of the Emissions(in percent) in Solomon Islands in 1988 to that in 1990?
Give a very brief answer. 1. What is the ratio of the Emissions(in percent) in Middle East & North Africa (all income levels) in 1988 to that in 1991?
Your answer should be compact. 1.06. What is the ratio of the Emissions(in percent) of Cote d'Ivoire in 1988 to that in 1991?
Offer a terse response. 1.01. What is the ratio of the Emissions(in percent) of Middle East & North Africa (all income levels) in 1988 to that in 1992?
Make the answer very short. 1.05. What is the ratio of the Emissions(in percent) of Cote d'Ivoire in 1988 to that in 1992?
Make the answer very short. 1.02. What is the ratio of the Emissions(in percent) of Middle East & North Africa (all income levels) in 1988 to that in 1993?
Offer a very short reply. 1.05. What is the ratio of the Emissions(in percent) of Solomon Islands in 1988 to that in 1993?
Offer a terse response. 1. What is the ratio of the Emissions(in percent) in Middle East & North Africa (all income levels) in 1988 to that in 1994?
Your answer should be very brief. 1.08. What is the ratio of the Emissions(in percent) in Cote d'Ivoire in 1988 to that in 1994?
Provide a short and direct response. 1.07. What is the ratio of the Emissions(in percent) of Solomon Islands in 1988 to that in 1994?
Your answer should be compact. 1. What is the ratio of the Emissions(in percent) in Middle East & North Africa (all income levels) in 1989 to that in 1990?
Provide a short and direct response. 1.04. What is the ratio of the Emissions(in percent) of Cote d'Ivoire in 1989 to that in 1990?
Offer a terse response. 1.01. What is the ratio of the Emissions(in percent) of French Polynesia in 1989 to that in 1990?
Make the answer very short. 1. What is the ratio of the Emissions(in percent) in Middle East & North Africa (all income levels) in 1989 to that in 1991?
Your answer should be compact. 1.05. What is the ratio of the Emissions(in percent) in Cote d'Ivoire in 1989 to that in 1991?
Ensure brevity in your answer.  1.02. What is the ratio of the Emissions(in percent) in French Polynesia in 1989 to that in 1991?
Provide a succinct answer. 1. What is the ratio of the Emissions(in percent) in Middle East & North Africa (all income levels) in 1989 to that in 1992?
Make the answer very short. 1.04. What is the ratio of the Emissions(in percent) in Cote d'Ivoire in 1989 to that in 1992?
Make the answer very short. 1.03. What is the ratio of the Emissions(in percent) of French Polynesia in 1989 to that in 1992?
Provide a short and direct response. 1. What is the ratio of the Emissions(in percent) in Solomon Islands in 1989 to that in 1992?
Your answer should be very brief. 1. What is the ratio of the Emissions(in percent) in Middle East & North Africa (all income levels) in 1989 to that in 1993?
Ensure brevity in your answer.  1.04. What is the ratio of the Emissions(in percent) in Cote d'Ivoire in 1989 to that in 1993?
Make the answer very short. 1.01. What is the ratio of the Emissions(in percent) in French Polynesia in 1989 to that in 1993?
Give a very brief answer. 1. What is the ratio of the Emissions(in percent) of Solomon Islands in 1989 to that in 1993?
Offer a very short reply. 1. What is the ratio of the Emissions(in percent) of Middle East & North Africa (all income levels) in 1989 to that in 1994?
Give a very brief answer. 1.06. What is the ratio of the Emissions(in percent) of Cote d'Ivoire in 1989 to that in 1994?
Your answer should be very brief. 1.08. What is the ratio of the Emissions(in percent) in Cote d'Ivoire in 1990 to that in 1991?
Offer a terse response. 1. What is the ratio of the Emissions(in percent) in French Polynesia in 1990 to that in 1991?
Give a very brief answer. 1. What is the ratio of the Emissions(in percent) of Middle East & North Africa (all income levels) in 1990 to that in 1992?
Give a very brief answer. 1. What is the ratio of the Emissions(in percent) in Cote d'Ivoire in 1990 to that in 1992?
Your response must be concise. 1.01. What is the ratio of the Emissions(in percent) of Solomon Islands in 1990 to that in 1992?
Your answer should be compact. 1. What is the ratio of the Emissions(in percent) in Cote d'Ivoire in 1990 to that in 1993?
Keep it short and to the point. 1. What is the ratio of the Emissions(in percent) in French Polynesia in 1990 to that in 1993?
Your answer should be compact. 1. What is the ratio of the Emissions(in percent) of Middle East & North Africa (all income levels) in 1990 to that in 1994?
Give a very brief answer. 1.02. What is the ratio of the Emissions(in percent) in Cote d'Ivoire in 1990 to that in 1994?
Provide a short and direct response. 1.07. What is the ratio of the Emissions(in percent) of Solomon Islands in 1990 to that in 1994?
Your answer should be very brief. 1. What is the ratio of the Emissions(in percent) in Middle East & North Africa (all income levels) in 1991 to that in 1992?
Your answer should be very brief. 0.99. What is the ratio of the Emissions(in percent) of Cote d'Ivoire in 1991 to that in 1992?
Your response must be concise. 1.01. What is the ratio of the Emissions(in percent) of Middle East & North Africa (all income levels) in 1991 to that in 1993?
Offer a very short reply. 0.99. What is the ratio of the Emissions(in percent) of Cote d'Ivoire in 1991 to that in 1993?
Offer a terse response. 1. What is the ratio of the Emissions(in percent) of Middle East & North Africa (all income levels) in 1991 to that in 1994?
Make the answer very short. 1.02. What is the ratio of the Emissions(in percent) in Cote d'Ivoire in 1991 to that in 1994?
Keep it short and to the point. 1.07. What is the ratio of the Emissions(in percent) of Solomon Islands in 1991 to that in 1994?
Keep it short and to the point. 1. What is the ratio of the Emissions(in percent) in Cote d'Ivoire in 1992 to that in 1993?
Provide a succinct answer. 0.99. What is the ratio of the Emissions(in percent) of French Polynesia in 1992 to that in 1993?
Provide a succinct answer. 1. What is the ratio of the Emissions(in percent) in Solomon Islands in 1992 to that in 1993?
Keep it short and to the point. 1. What is the ratio of the Emissions(in percent) of Middle East & North Africa (all income levels) in 1992 to that in 1994?
Make the answer very short. 1.02. What is the ratio of the Emissions(in percent) of Cote d'Ivoire in 1992 to that in 1994?
Make the answer very short. 1.06. What is the ratio of the Emissions(in percent) in Middle East & North Africa (all income levels) in 1993 to that in 1994?
Offer a very short reply. 1.02. What is the ratio of the Emissions(in percent) of Cote d'Ivoire in 1993 to that in 1994?
Make the answer very short. 1.07. What is the ratio of the Emissions(in percent) in French Polynesia in 1993 to that in 1994?
Give a very brief answer. 1. What is the difference between the highest and the second highest Emissions(in percent) in Middle East & North Africa (all income levels)?
Your response must be concise. 0.73. What is the difference between the highest and the second highest Emissions(in percent) in Cote d'Ivoire?
Offer a very short reply. 0.88. What is the difference between the highest and the lowest Emissions(in percent) of Middle East & North Africa (all income levels)?
Offer a terse response. 4.41. What is the difference between the highest and the lowest Emissions(in percent) of Cote d'Ivoire?
Provide a short and direct response. 7.55. What is the difference between the highest and the lowest Emissions(in percent) in French Polynesia?
Offer a terse response. 0. 